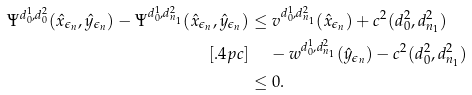Convert formula to latex. <formula><loc_0><loc_0><loc_500><loc_500>\Psi ^ { d _ { 0 } ^ { 1 } , d _ { 0 } ^ { 2 } } ( \hat { x } _ { \epsilon _ { n } } , \hat { y } _ { \epsilon _ { n } } ) - \Psi ^ { d _ { 0 } ^ { 1 } , d _ { n _ { 1 } } ^ { 2 } } ( \hat { x } _ { \epsilon _ { n } } , \hat { y } _ { \epsilon _ { n } } ) & \leq v ^ { d _ { 0 } ^ { 1 } , d _ { n _ { 1 } } ^ { 2 } } ( \hat { x } _ { \epsilon _ { n } } ) + c ^ { 2 } ( d ^ { 2 } _ { 0 } , d _ { n _ { 1 } } ^ { 2 } ) \\ [ . 4 p c ] & \quad \, - w ^ { d _ { 0 } ^ { 1 } , d _ { n _ { 1 } } ^ { 2 } } ( \hat { y } _ { \epsilon _ { n } } ) - c ^ { 2 } ( d ^ { 2 } _ { 0 } , d _ { n _ { 1 } } ^ { 2 } ) \\ & \leq 0 .</formula> 